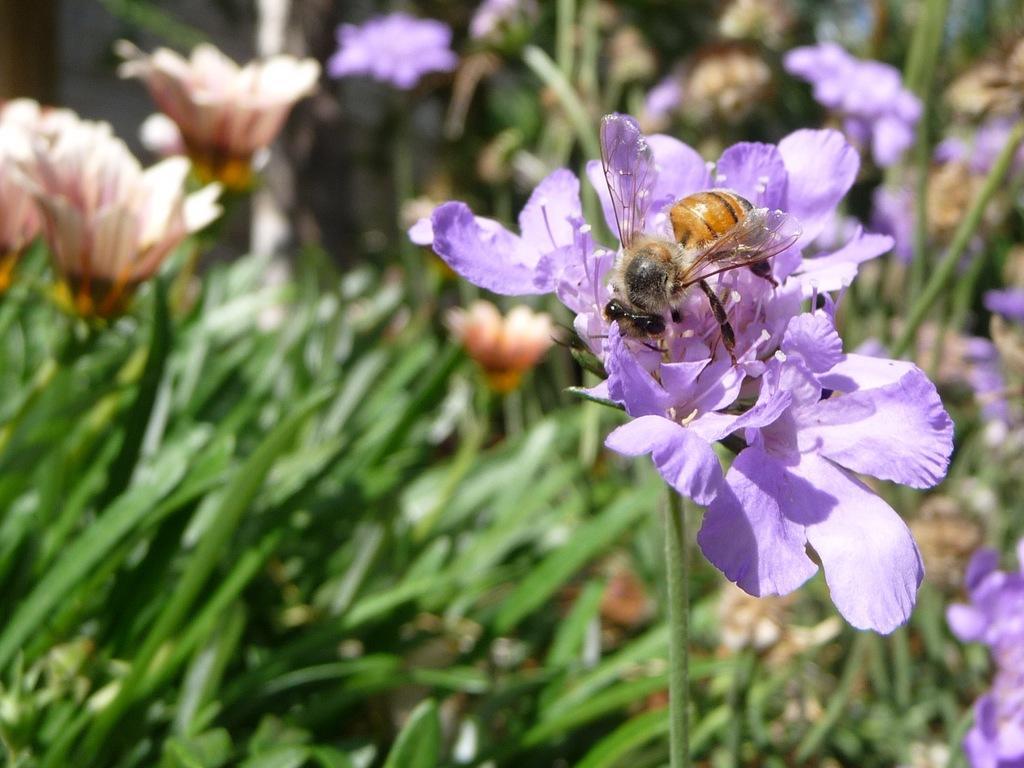In one or two sentences, can you explain what this image depicts? In this image we can see there is an insect on the flower and at the back there are plants with flowers. 